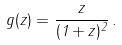Convert formula to latex. <formula><loc_0><loc_0><loc_500><loc_500>g ( z ) = \frac { z } { ( 1 + z ) ^ { 2 } } \, .</formula> 